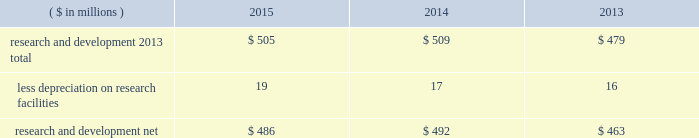38 2015 ppg annual report and form 10-k notes to the consolidated financial statements 1 .
Summary of significant accounting policies principles of consolidation the accompanying consolidated financial statements include the accounts of ppg industries , inc .
( 201cppg 201d or the 201ccompany 201d ) and all subsidiaries , both u.s .
And non-u.s. , that it controls .
Ppg owns more than 50% ( 50 % ) of the voting stock of most of the subsidiaries that it controls .
For those consolidated subsidiaries in which the company 2019s ownership is less than 100% ( 100 % ) , the outside shareholders 2019 interests are shown as noncontrolling interests .
Investments in companies in which ppg owns 20% ( 20 % ) to 50% ( 50 % ) of the voting stock and has the ability to exercise significant influence over operating and financial policies of the investee are accounted for using the equity method of accounting .
As a result , ppg 2019s share of the earnings or losses of such equity affiliates is included in the accompanying consolidated statement of income and ppg 2019s share of these companies 2019 shareholders 2019 equity is included in 201cinvestments 201d in the accompanying consolidated balance sheet .
Transactions between ppg and its subsidiaries are eliminated in consolidation .
Use of estimates in the preparation of financial statements the preparation of financial statements in conformity with u.s .
Generally accepted accounting principles requires management to make estimates and assumptions that affect the reported amounts of assets and liabilities and the disclosure of contingent assets and liabilities at the date of the financial statements , as well as the reported amounts of income and expenses during the reporting period .
Such estimates also include the fair value of assets acquired and liabilities assumed resulting from the allocation of the purchase price related to business combinations consummated .
Actual outcomes could differ from those estimates .
Revenue recognition the company recognizes revenue when the earnings process is complete .
Revenue from sales is recognized by all operating segments when goods are shipped and title to inventory and risk of loss passes to the customer or when services have been rendered .
Shipping and handling costs amounts billed to customers for shipping and handling are reported in 201cnet sales 201d in the accompanying consolidated statement of income .
Shipping and handling costs incurred by the company for the delivery of goods to customers are included in 201ccost of sales , exclusive of depreciation and amortization 201d in the accompanying consolidated statement of income .
Selling , general and administrative costs amounts presented as 201cselling , general and administrative 201d in the accompanying consolidated statement of income are comprised of selling , customer service , distribution and advertising costs , as well as the costs of providing corporate- wide functional support in such areas as finance , law , human resources and planning .
Distribution costs pertain to the movement and storage of finished goods inventory at company- owned and leased warehouses , terminals and other distribution facilities .
Advertising costs advertising costs are expensed as incurred and totaled $ 324 million , $ 297 million and $ 235 million in 2015 , 2014 and 2013 , respectively .
Research and development research and development costs , which consist primarily of employee related costs , are charged to expense as incurred. .
Legal costs legal costs , primarily include costs associated with acquisition and divestiture transactions , general litigation , environmental regulation compliance , patent and trademark protection and other general corporate purposes , are charged to expense as incurred .
Foreign currency translation the functional currency of most significant non-u.s .
Operations is their local currency .
Assets and liabilities of those operations are translated into u.s .
Dollars using year-end exchange rates ; income and expenses are translated using the average exchange rates for the reporting period .
Unrealized foreign currency translation adjustments are deferred in accumulated other comprehensive loss , a separate component of shareholders 2019 equity .
Cash equivalents cash equivalents are highly liquid investments ( valued at cost , which approximates fair value ) acquired with an original maturity of three months or less .
Short-term investments short-term investments are highly liquid , high credit quality investments ( valued at cost plus accrued interest ) that have stated maturities of greater than three months to one year .
The purchases and sales of these investments are classified as investing activities in the consolidated statement of cash flows .
Marketable equity securities the company 2019s investment in marketable equity securities is recorded at fair market value and reported in 201cother current assets 201d and 201cinvestments 201d in the accompanying consolidated balance sheet with changes in fair market value recorded in income for those securities designated as trading securities and in other comprehensive income , net of tax , for those designated as available for sale securities. .
What was the percentage change in research and development 2013 total from 2014 to 2015? 
Computations: ((505 - 509) / 509)
Answer: -0.00786. 